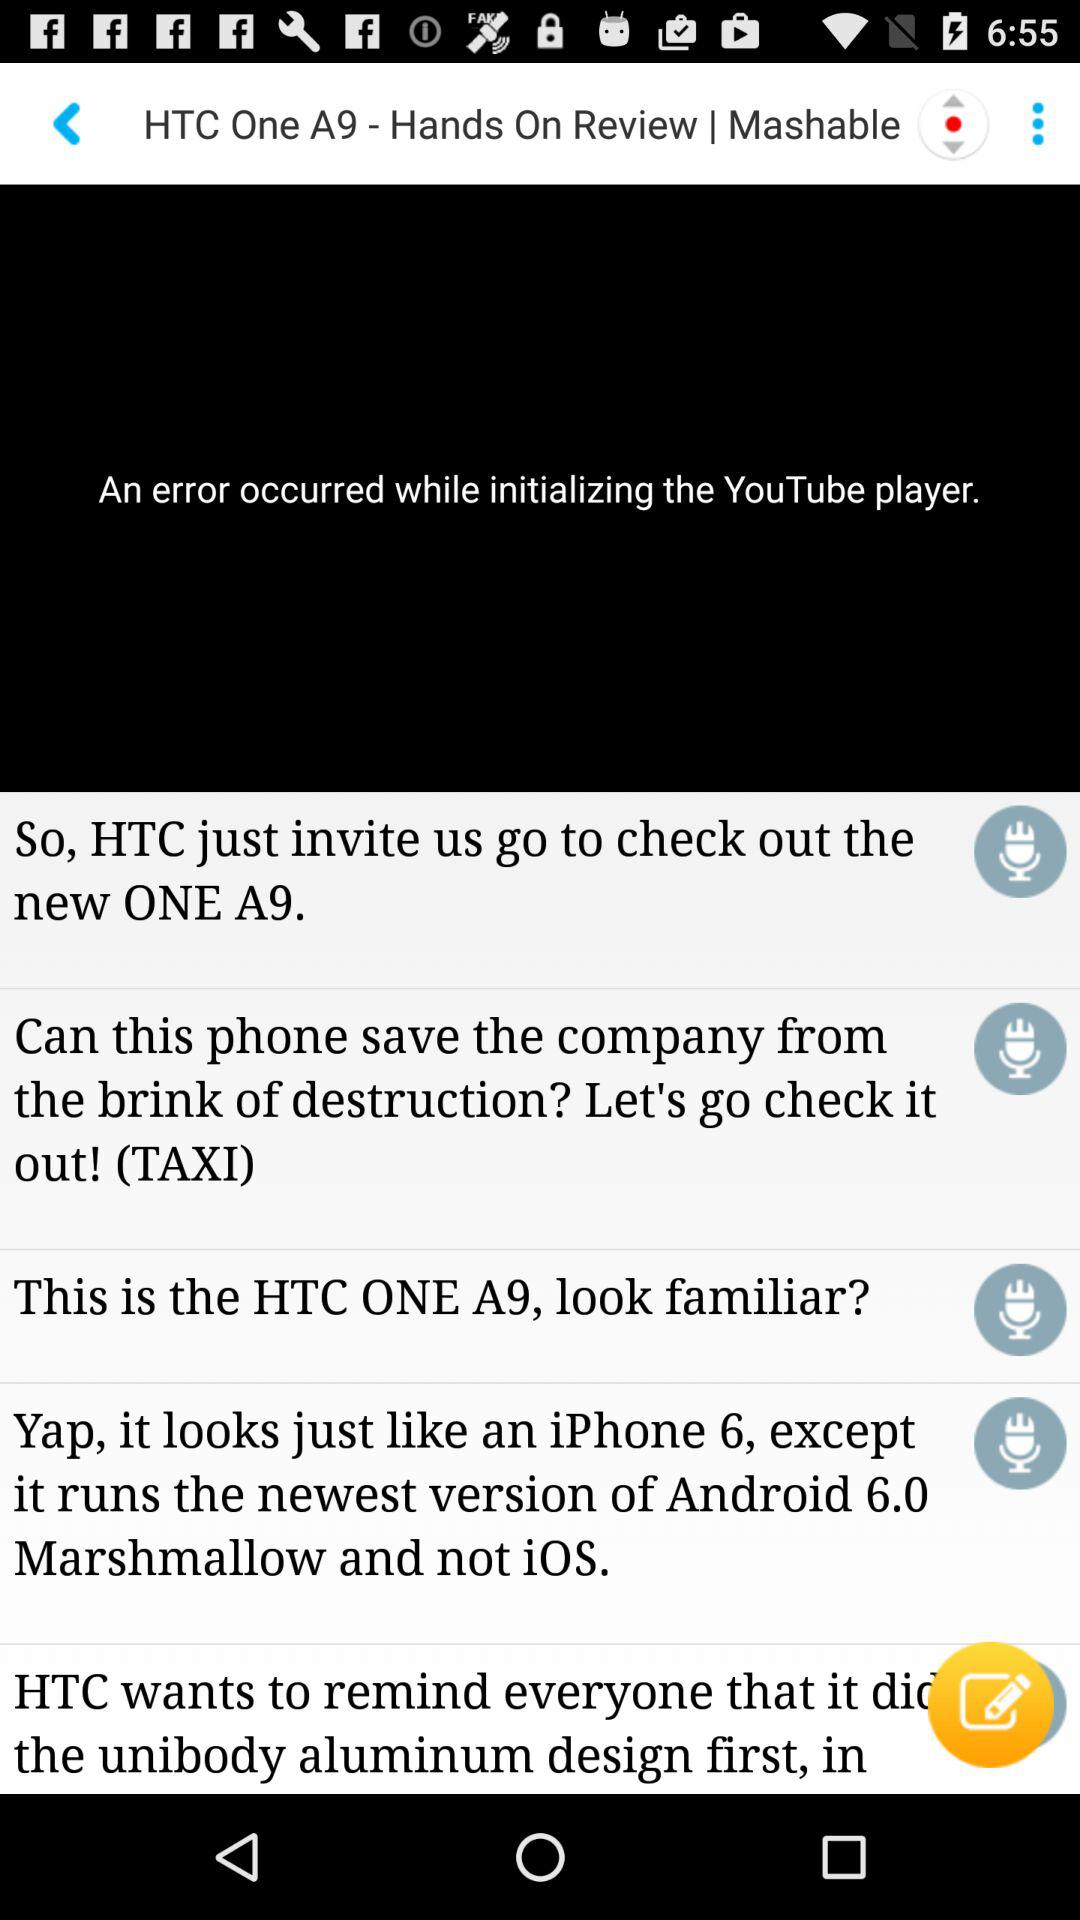What is new in HTC One A9?
When the provided information is insufficient, respond with <no answer>. <no answer> 